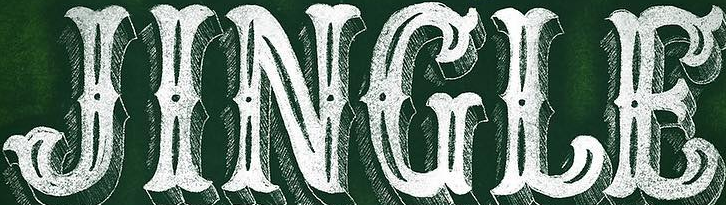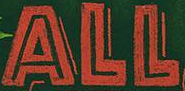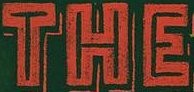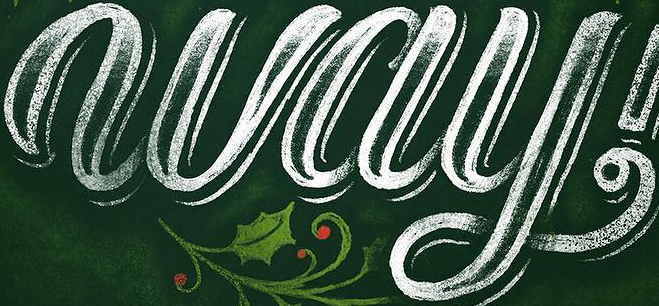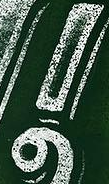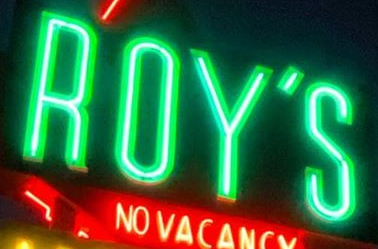Transcribe the words shown in these images in order, separated by a semicolon. JINGLE; ALL; THE; way; !; ROY'S 